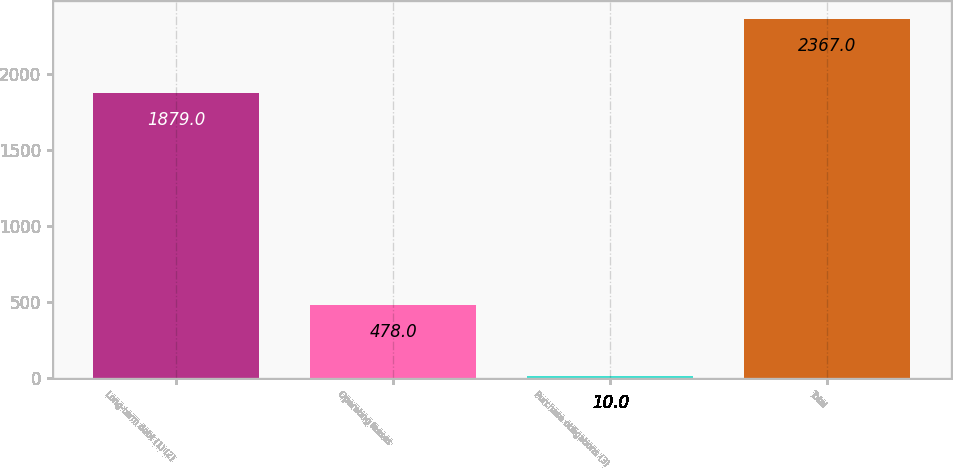Convert chart. <chart><loc_0><loc_0><loc_500><loc_500><bar_chart><fcel>Long-term debt (1) (2)<fcel>Operating leases<fcel>Purchase obligations (3)<fcel>Total<nl><fcel>1879<fcel>478<fcel>10<fcel>2367<nl></chart> 